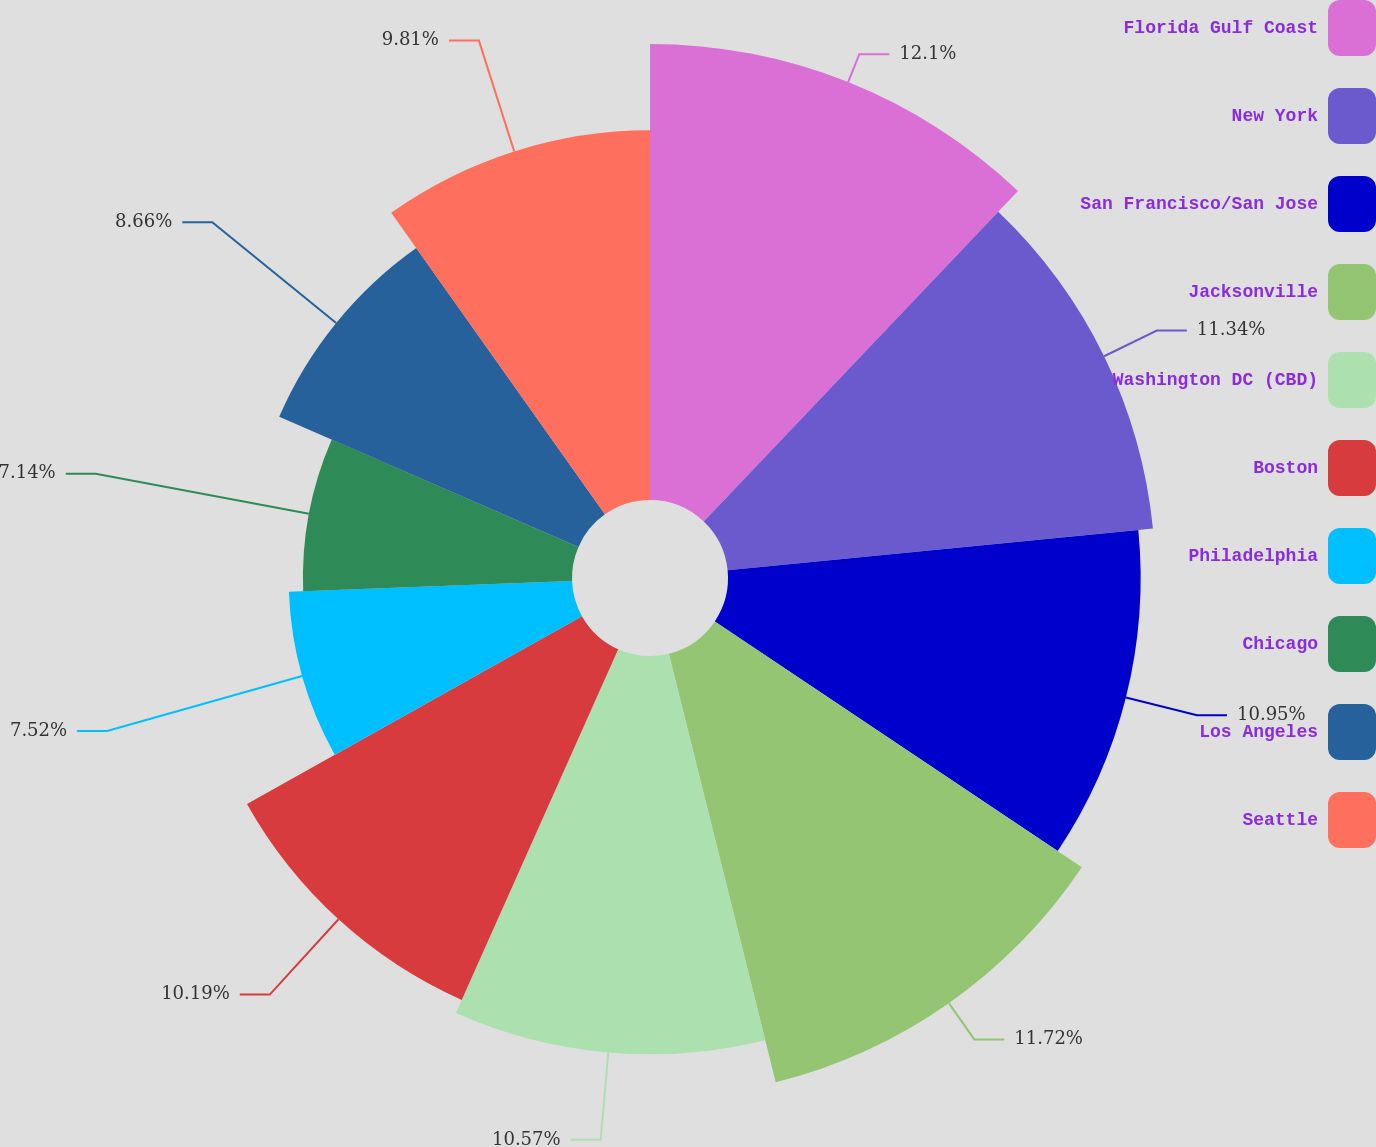Convert chart to OTSL. <chart><loc_0><loc_0><loc_500><loc_500><pie_chart><fcel>Florida Gulf Coast<fcel>New York<fcel>San Francisco/San Jose<fcel>Jacksonville<fcel>Washington DC (CBD)<fcel>Boston<fcel>Philadelphia<fcel>Chicago<fcel>Los Angeles<fcel>Seattle<nl><fcel>12.1%<fcel>11.34%<fcel>10.95%<fcel>11.72%<fcel>10.57%<fcel>10.19%<fcel>7.52%<fcel>7.14%<fcel>8.66%<fcel>9.81%<nl></chart> 